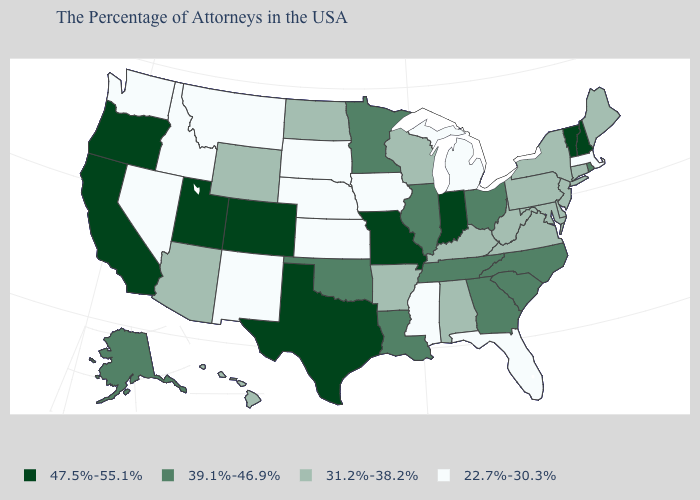Does the map have missing data?
Quick response, please. No. Name the states that have a value in the range 31.2%-38.2%?
Quick response, please. Maine, Connecticut, New York, New Jersey, Delaware, Maryland, Pennsylvania, Virginia, West Virginia, Kentucky, Alabama, Wisconsin, Arkansas, North Dakota, Wyoming, Arizona, Hawaii. Does Maine have a higher value than Michigan?
Short answer required. Yes. Among the states that border Indiana , which have the lowest value?
Give a very brief answer. Michigan. Name the states that have a value in the range 47.5%-55.1%?
Concise answer only. New Hampshire, Vermont, Indiana, Missouri, Texas, Colorado, Utah, California, Oregon. What is the value of Oklahoma?
Keep it brief. 39.1%-46.9%. Name the states that have a value in the range 31.2%-38.2%?
Keep it brief. Maine, Connecticut, New York, New Jersey, Delaware, Maryland, Pennsylvania, Virginia, West Virginia, Kentucky, Alabama, Wisconsin, Arkansas, North Dakota, Wyoming, Arizona, Hawaii. Which states hav the highest value in the Northeast?
Be succinct. New Hampshire, Vermont. Name the states that have a value in the range 39.1%-46.9%?
Be succinct. Rhode Island, North Carolina, South Carolina, Ohio, Georgia, Tennessee, Illinois, Louisiana, Minnesota, Oklahoma, Alaska. Does Mississippi have the lowest value in the South?
Answer briefly. Yes. Among the states that border Massachusetts , does New York have the highest value?
Give a very brief answer. No. Does New Hampshire have the lowest value in the Northeast?
Answer briefly. No. Does Rhode Island have the lowest value in the USA?
Quick response, please. No. Name the states that have a value in the range 31.2%-38.2%?
Write a very short answer. Maine, Connecticut, New York, New Jersey, Delaware, Maryland, Pennsylvania, Virginia, West Virginia, Kentucky, Alabama, Wisconsin, Arkansas, North Dakota, Wyoming, Arizona, Hawaii. Name the states that have a value in the range 47.5%-55.1%?
Keep it brief. New Hampshire, Vermont, Indiana, Missouri, Texas, Colorado, Utah, California, Oregon. 